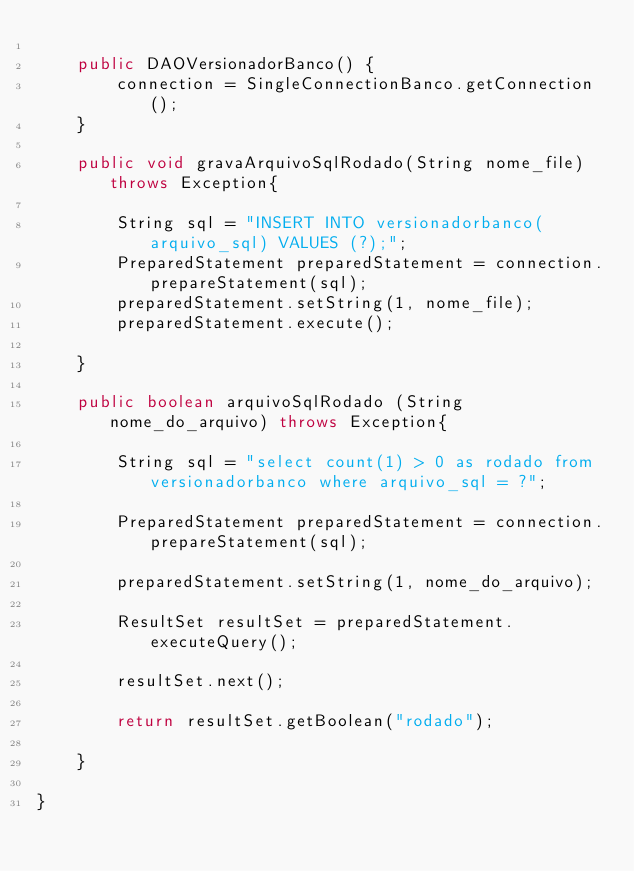Convert code to text. <code><loc_0><loc_0><loc_500><loc_500><_Java_>	
	public DAOVersionadorBanco() {
		connection = SingleConnectionBanco.getConnection();
	}
	
	public void gravaArquivoSqlRodado(String nome_file) throws Exception{
		
		String sql = "INSERT INTO versionadorbanco(arquivo_sql) VALUES (?);";
		PreparedStatement preparedStatement = connection.prepareStatement(sql);
		preparedStatement.setString(1, nome_file);
		preparedStatement.execute();
		
	}
	
	public boolean arquivoSqlRodado (String nome_do_arquivo) throws Exception{
		
		String sql = "select count(1) > 0 as rodado from versionadorbanco where arquivo_sql = ?";
		
		PreparedStatement preparedStatement = connection.prepareStatement(sql);
		
		preparedStatement.setString(1, nome_do_arquivo);
		
		ResultSet resultSet = preparedStatement.executeQuery();
		
		resultSet.next();
		
		return resultSet.getBoolean("rodado");
		
	}
	
}
</code> 